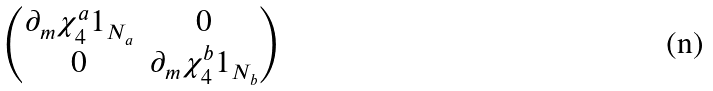<formula> <loc_0><loc_0><loc_500><loc_500>\begin{pmatrix} \partial _ { m } \chi ^ { a } _ { 4 } { 1 } _ { N _ { a } } & 0 \\ 0 & \partial _ { m } \chi ^ { b } _ { 4 } { 1 } _ { N _ { b } } \end{pmatrix}</formula> 